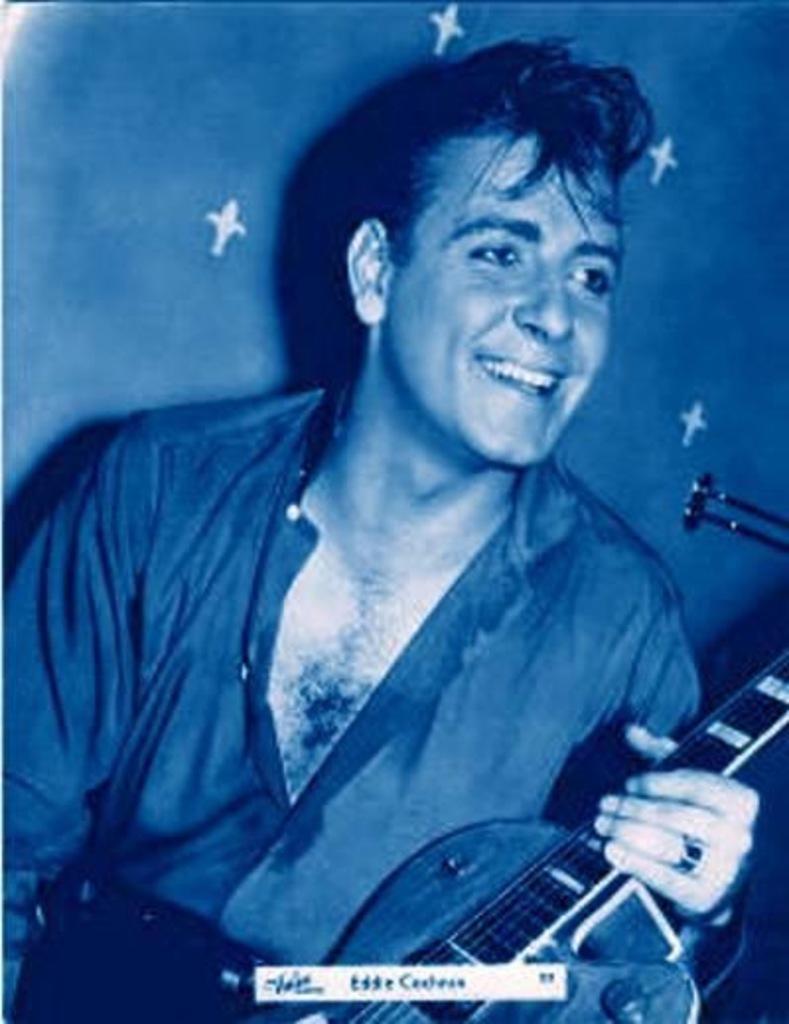In one or two sentences, can you explain what this image depicts? In the image there is a man holding a guitar and he is also having smile on his face. 